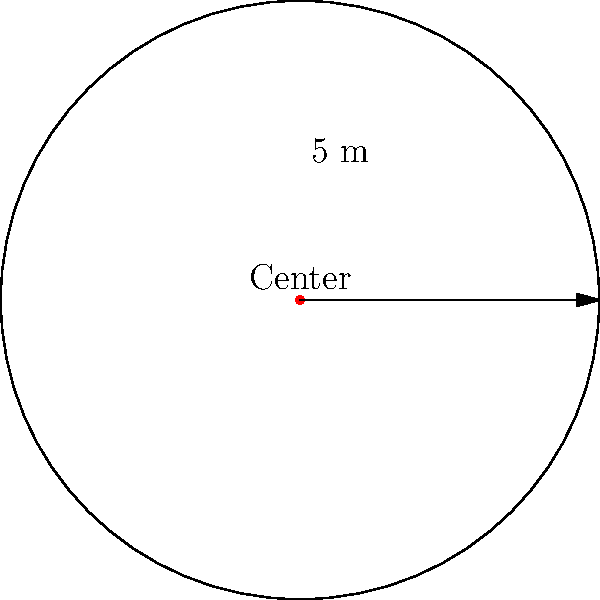In an ancient Polynesian ritual site, archaeologists have discovered a circular stone arrangement. The radius of this arrangement is 5 meters. What is the perimeter of this circular formation, and how might this information contribute to our understanding of the spatial dynamics in Polynesian ritualistic practices? (Use $\pi = 3.14$ for calculations) To find the perimeter of the circular stone arrangement, we need to calculate its circumference. The formula for the circumference of a circle is:

$$C = 2\pi r$$

Where:
$C$ = circumference
$\pi$ = pi (approximately 3.14)
$r$ = radius

Given:
$r = 5$ meters
$\pi = 3.14$

Step 1: Substitute the values into the formula:
$$C = 2 \times 3.14 \times 5$$

Step 2: Multiply:
$$C = 31.4 \text{ meters}$$

This perimeter of 31.4 meters provides valuable information about the spatial organization of Polynesian ritual sites. It helps us understand:

1. The scale of communal gatherings: The size suggests how many people could participate in rituals around the circle.
2. Spatial symbolism: The perfect circular shape might represent cosmic or spiritual concepts in Polynesian culture.
3. Resource allocation: The effort required to create such a precise circle indicates the importance of the site.
4. Social hierarchy: The positioning of participants around the circle might reflect social status or roles within the community.
5. Astronomical alignments: The size and orientation of the circle could be related to celestial observations important in Polynesian culture.

Understanding these spatial dynamics enhances our comprehension of Polynesian social structures, religious practices, and community organization in ancient times.
Answer: 31.4 meters 